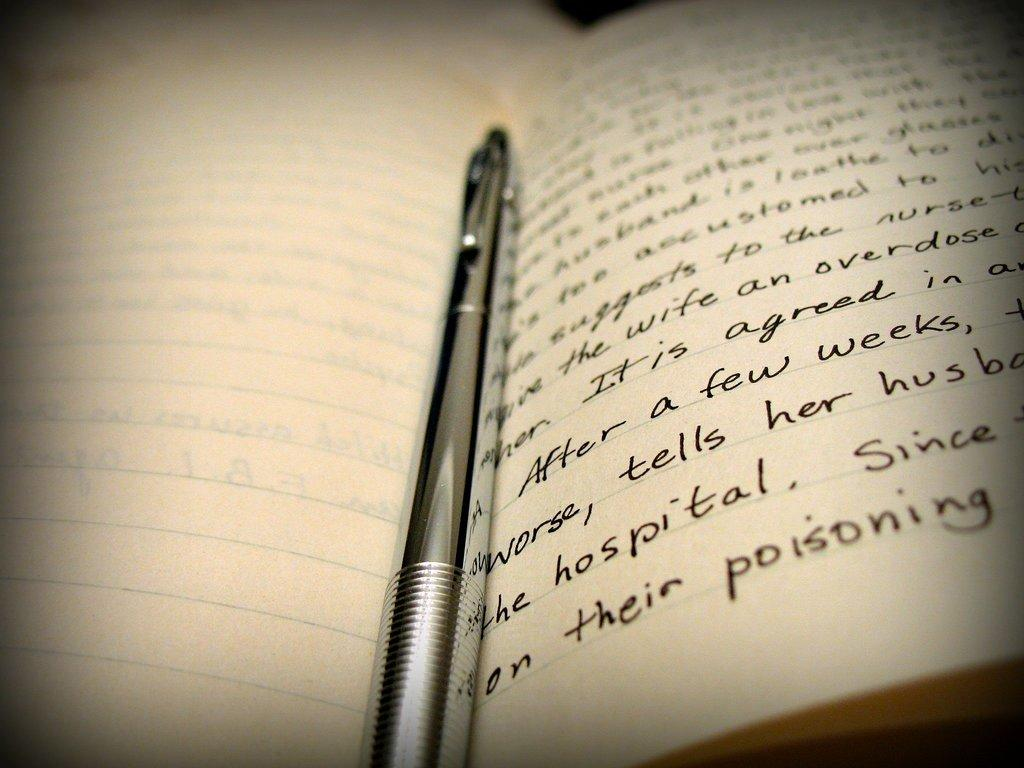What object is present in the picture that is commonly used for writing? There is a notebook in the picture, which is commonly used for writing. Can you describe what is inside the notebook? There is writing in the notebook. What is located in the center of the picture? There is a pen in the center of the picture. What is the visual quality of the edges of the image? The edges of the image are blurred. What historical event is being discussed in the notebook? There is no information about any historical event being discussed in the notebook; it only contains writing. How many frogs are visible in the picture? There are no frogs present in the picture. 